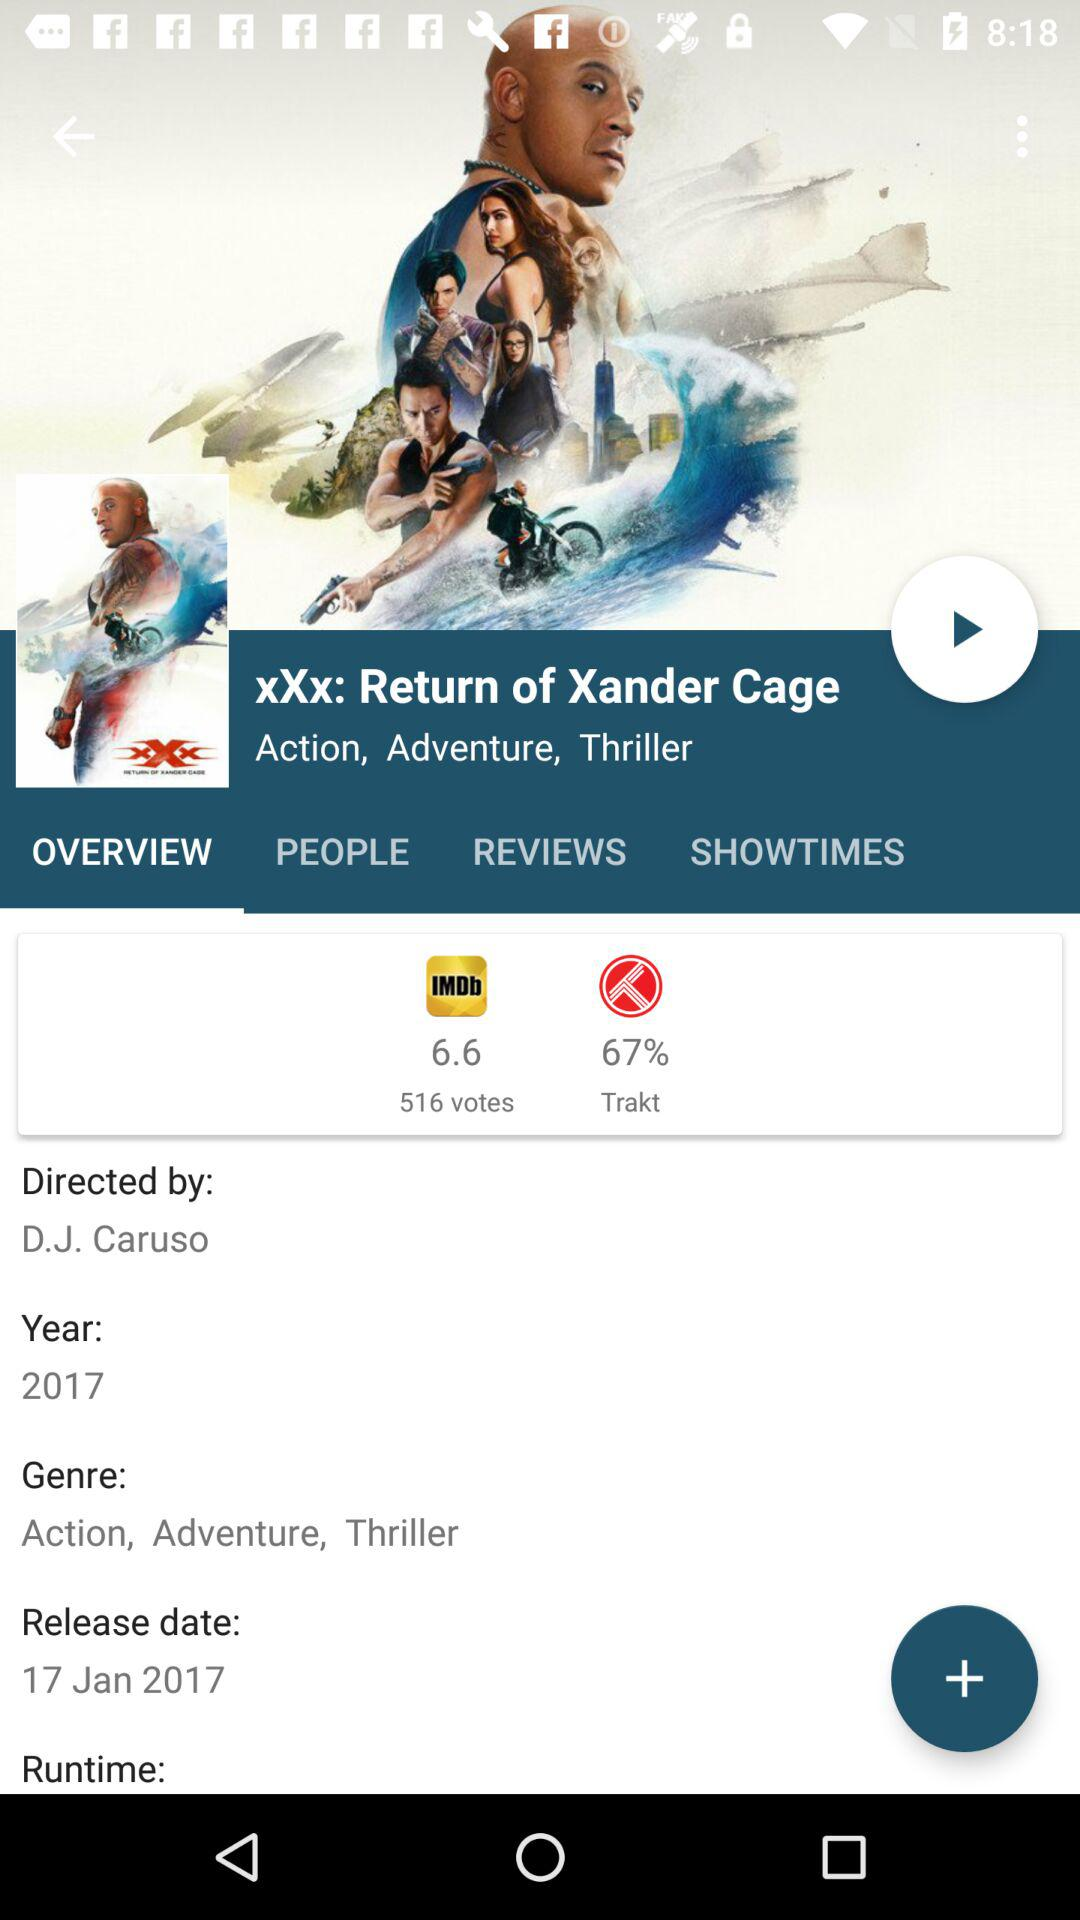Which tab is selected? The selected tab is "OVERVIEW". 